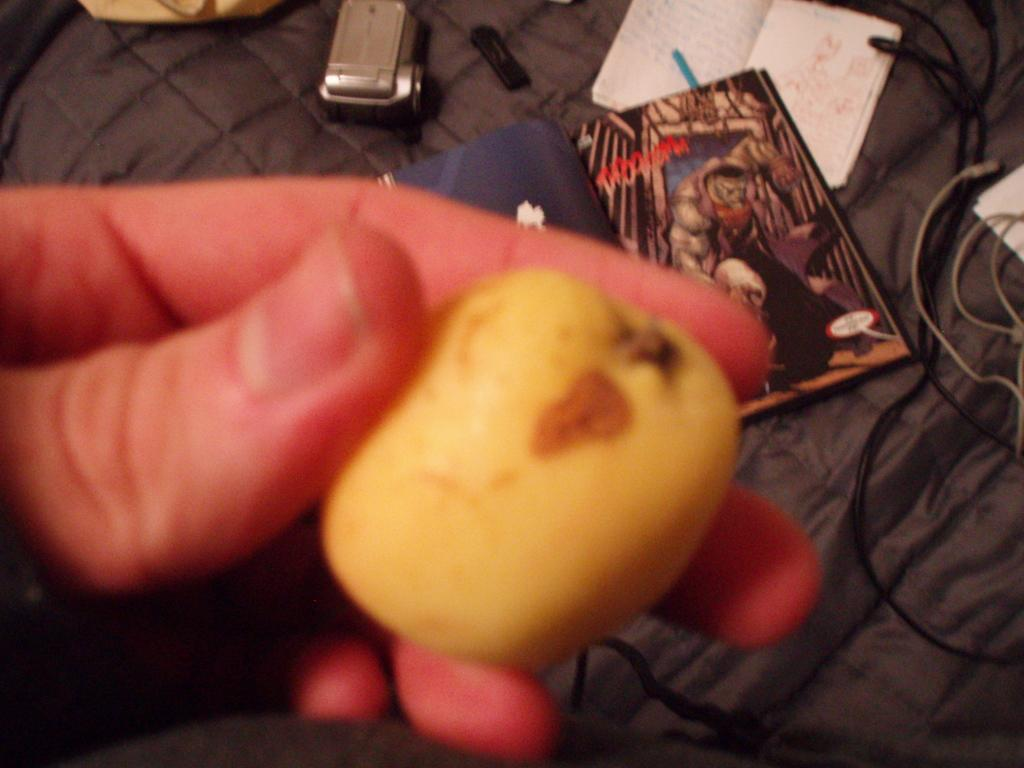What is the person's hand holding in the image? There is a person's hand holding an object in the image, but the specific object is not mentioned in the facts. What can be seen in the background of the image? There are books, a camera, and other objects on a cloth surface in the background of the image. Can you describe the objects on the cloth surface? The facts do not provide specific details about the objects on the cloth surface, so we cannot describe them. What type of station does the person's hand belong to in the image? There is no information about a station or any connection to a station in the image. 